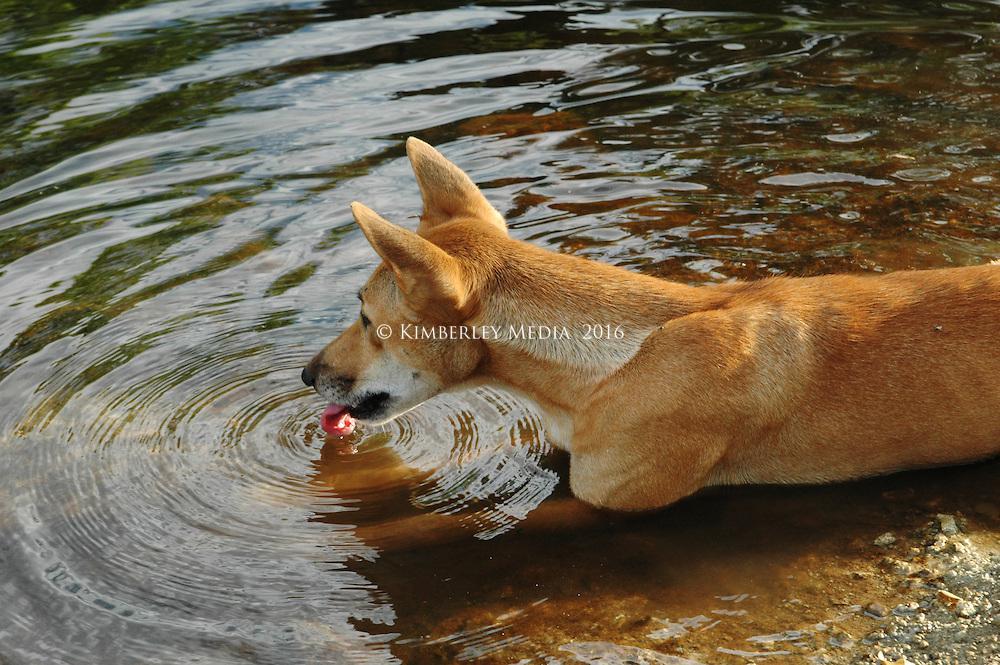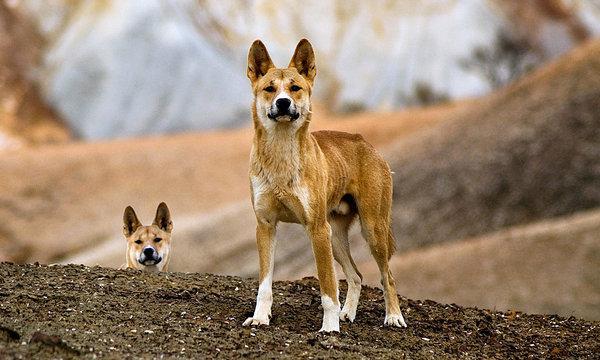The first image is the image on the left, the second image is the image on the right. Analyze the images presented: Is the assertion "One of the dingo images includes a natural body of water, and the other features a dog standing upright in the foreground." valid? Answer yes or no. Yes. The first image is the image on the left, the second image is the image on the right. Evaluate the accuracy of this statement regarding the images: "The right image shows at least one wild dog with a prey in its mouth.". Is it true? Answer yes or no. No. 